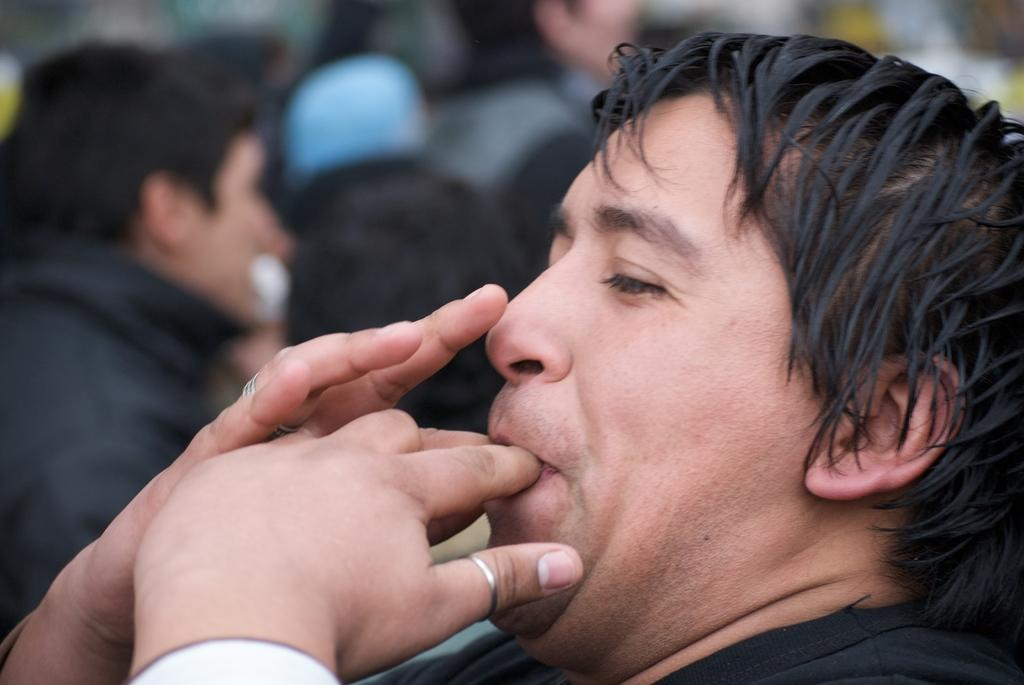What is the main subject in the foreground of the image? There is a person in the foreground of the image. What is the person doing with their fingers in the image? The person has their fingers on their mouth. Can you describe what might be happening in the background of the image? There might be a crowd in the background of the image. What type of polish is the person applying to their nails in the image? There is no indication of nail polish or any nail-related activity in the image. Can you see a carriage in the image? There is no carriage present in the image. 